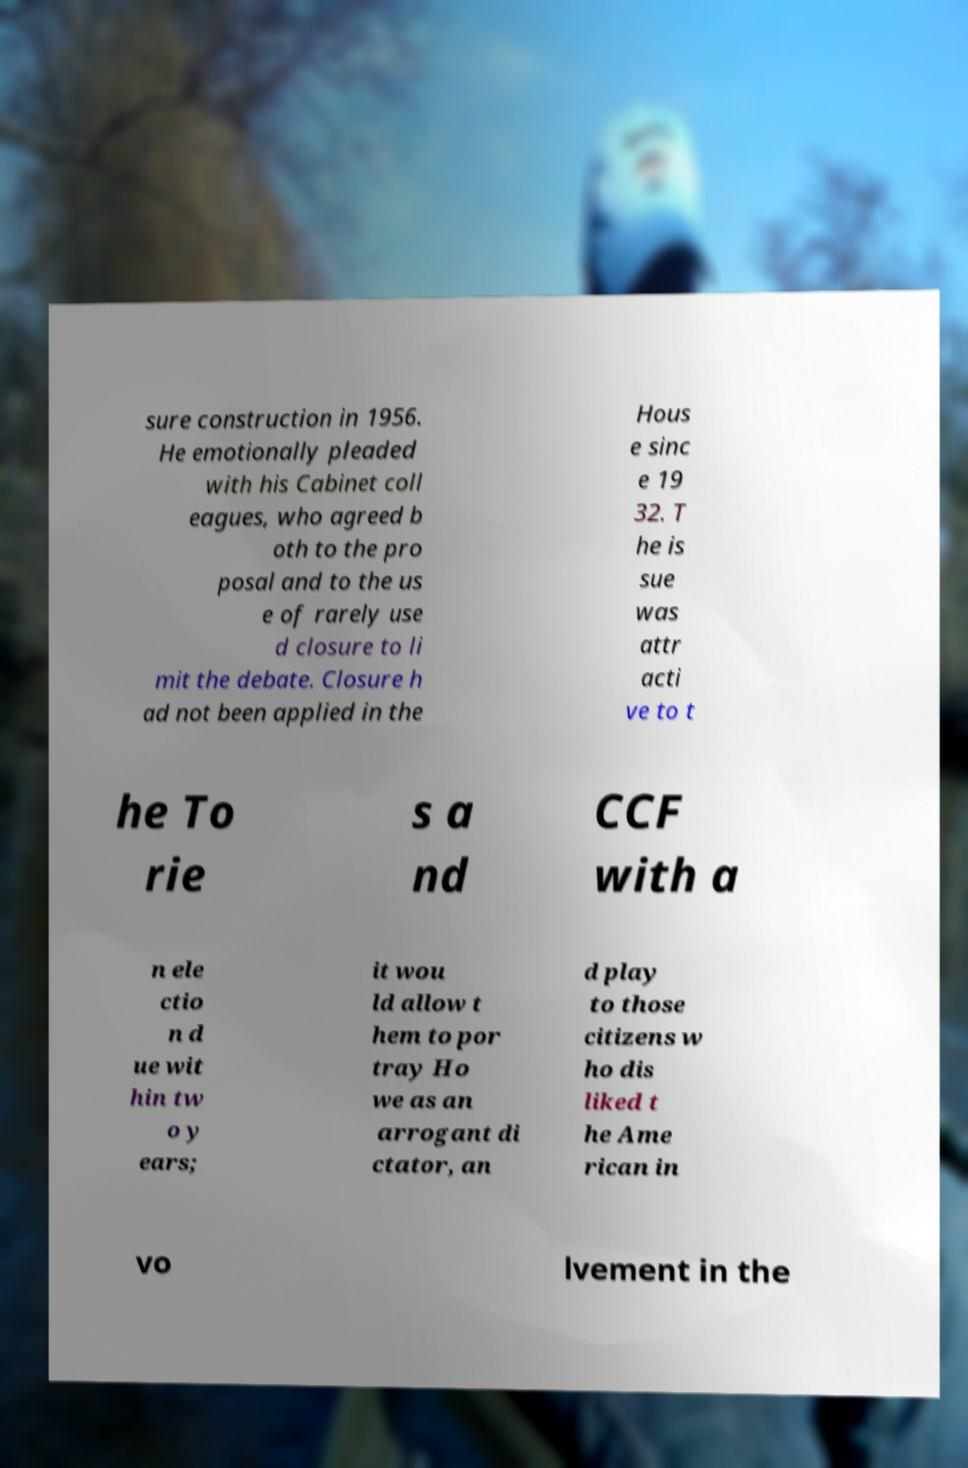Please identify and transcribe the text found in this image. sure construction in 1956. He emotionally pleaded with his Cabinet coll eagues, who agreed b oth to the pro posal and to the us e of rarely use d closure to li mit the debate. Closure h ad not been applied in the Hous e sinc e 19 32. T he is sue was attr acti ve to t he To rie s a nd CCF with a n ele ctio n d ue wit hin tw o y ears; it wou ld allow t hem to por tray Ho we as an arrogant di ctator, an d play to those citizens w ho dis liked t he Ame rican in vo lvement in the 